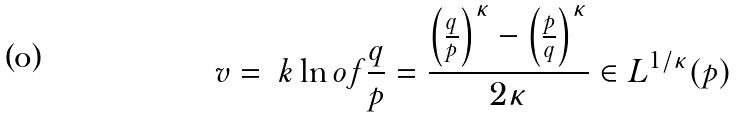Convert formula to latex. <formula><loc_0><loc_0><loc_500><loc_500>v = \ k \ln o f { \frac { q } { p } } = \frac { \left ( \frac { q } { p } \right ) ^ { \kappa } - \left ( \frac { p } { q } \right ) ^ { \kappa } } { 2 \kappa } \in L ^ { 1 / \kappa } ( p )</formula> 